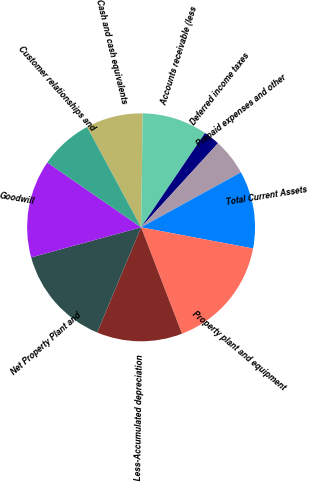Convert chart. <chart><loc_0><loc_0><loc_500><loc_500><pie_chart><fcel>Cash and cash equivalents<fcel>Accounts receivable (less<fcel>Deferred income taxes<fcel>Prepaid expenses and other<fcel>Total Current Assets<fcel>Property plant and equipment<fcel>Less-Accumulated depreciation<fcel>Net Property Plant and<fcel>Goodwill<fcel>Customer relationships and<nl><fcel>8.09%<fcel>9.25%<fcel>2.31%<fcel>5.2%<fcel>10.98%<fcel>16.18%<fcel>12.14%<fcel>14.45%<fcel>13.87%<fcel>7.51%<nl></chart> 